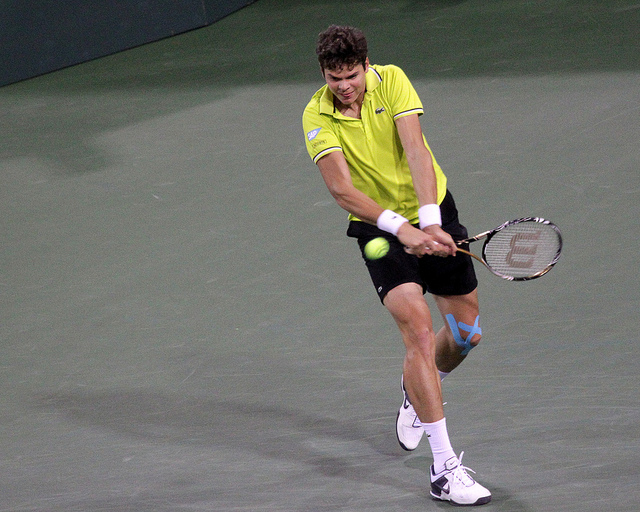Please identify all text content in this image. 8 